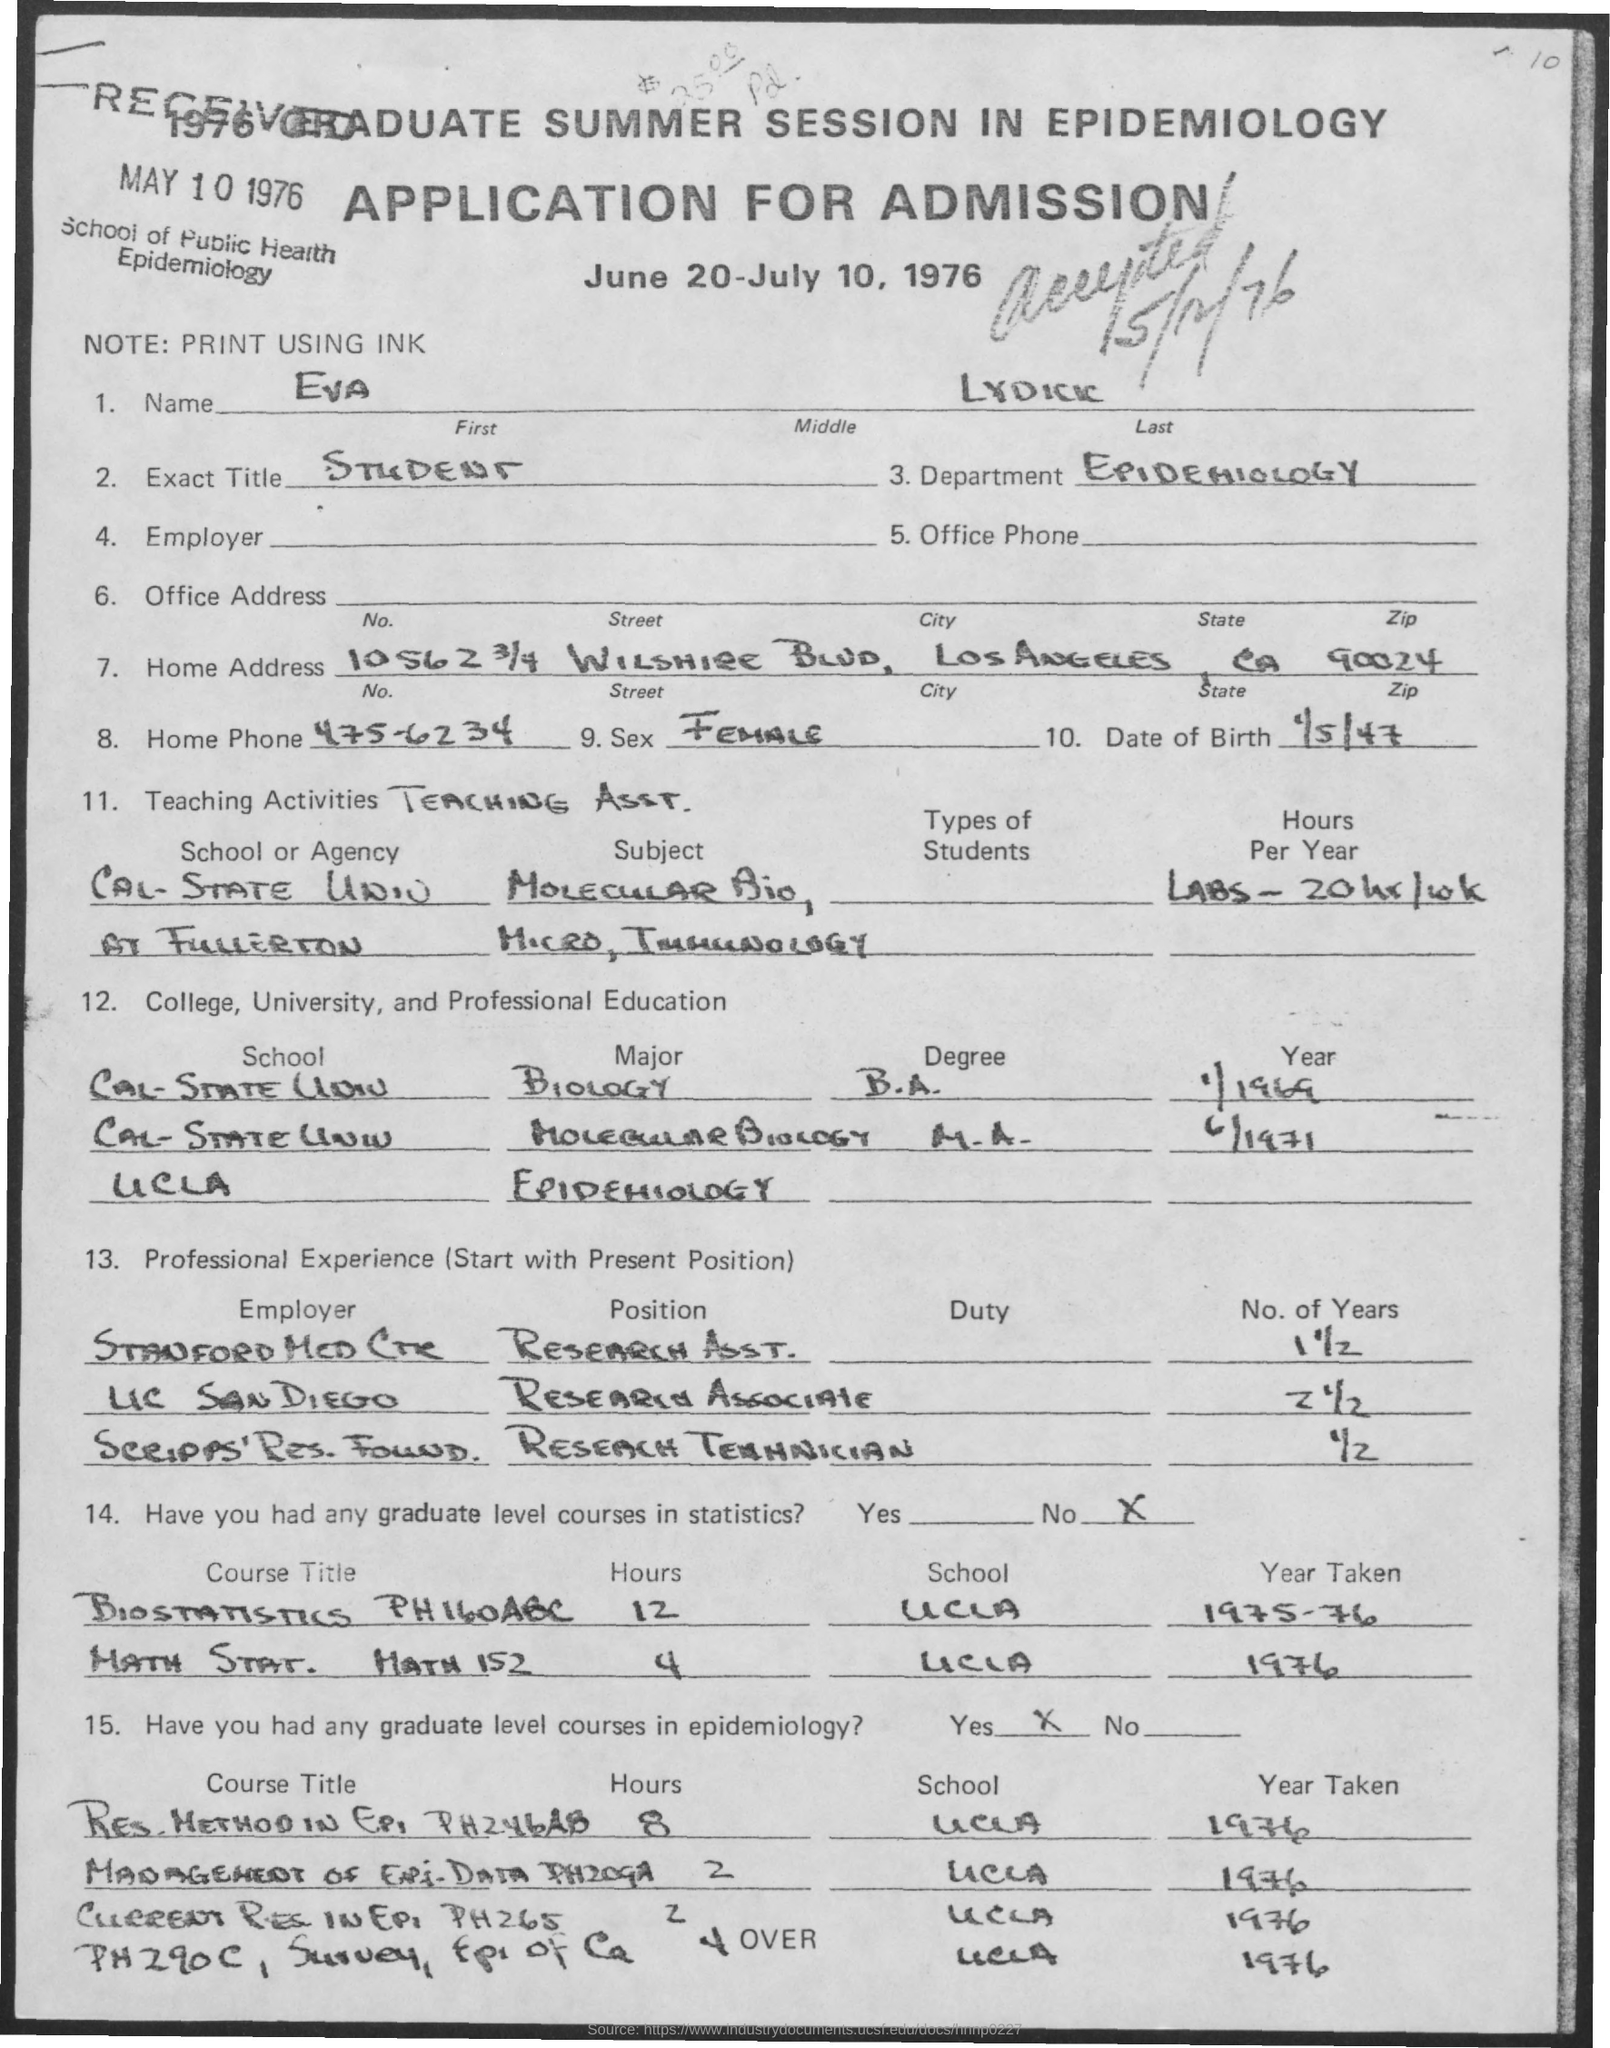List a handful of essential elements in this visual. I, [Name], am a student. Los Angeles is the city that is known as the City of Angels. The date of birth is January 5, 1947. The Department of Epidemiology is devoted to understanding the causes and patterns of disease and health in human populations. The home phone number is 475-6234. 